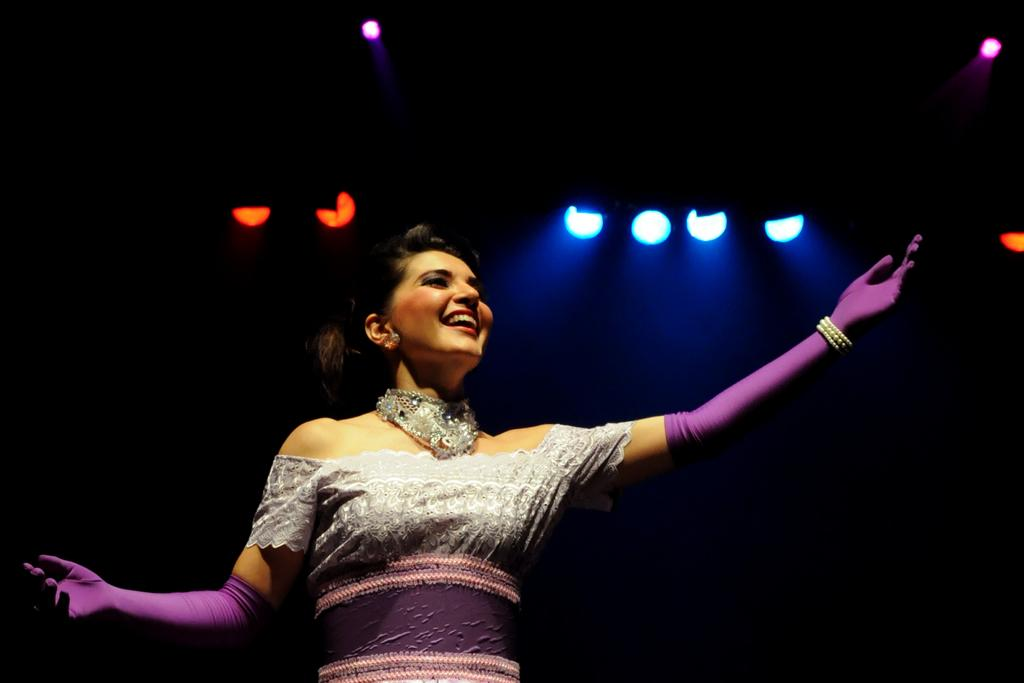Who is present in the image? There is a woman in the image. What is the woman's expression? The woman is smiling. What can be seen in the background of the image? There are lights visible in the background of the image. Can you describe the lighting conditions in the image? The image appears to be taken in a dark environment. What type of wrench is the woman using in the image? There is no wrench present in the image; it features a woman smiling in a dark environment with lights visible in the background. 